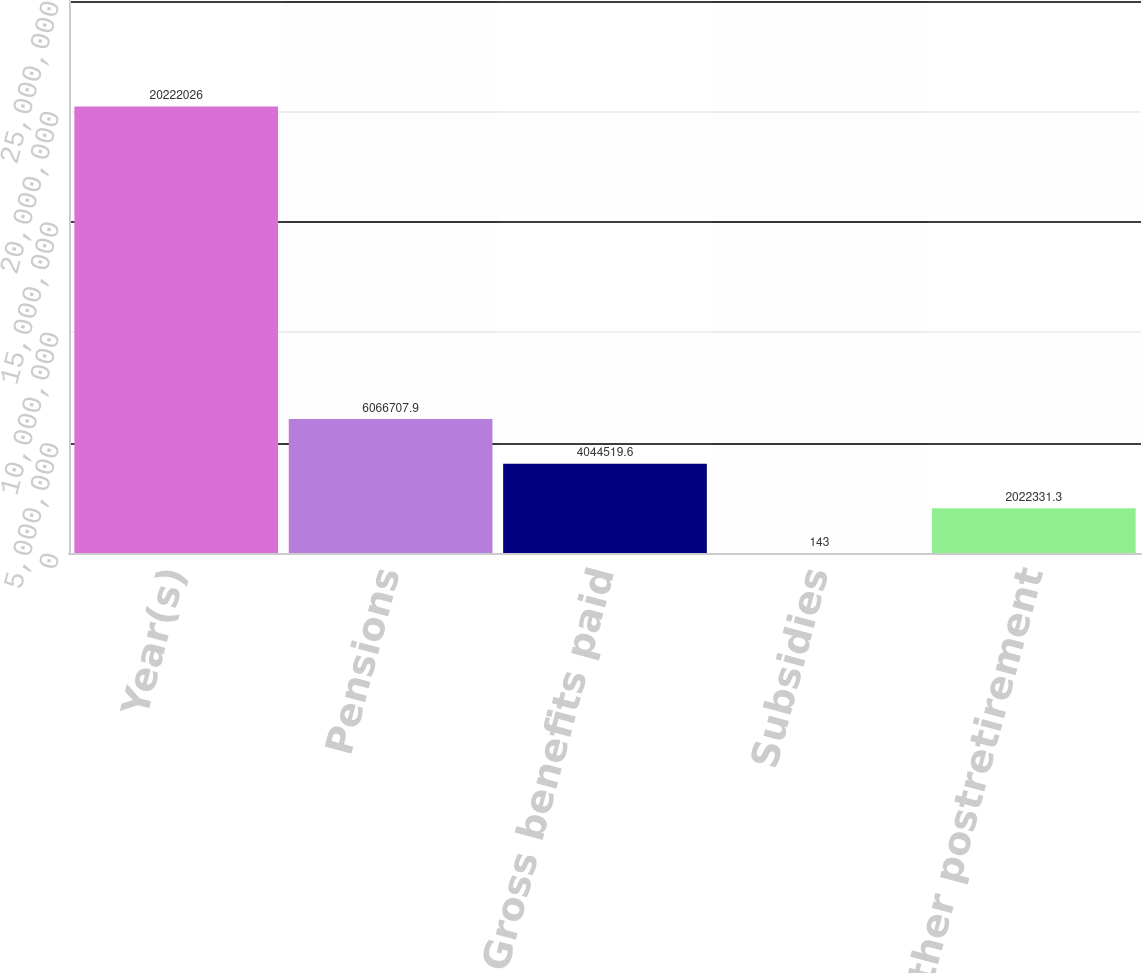Convert chart. <chart><loc_0><loc_0><loc_500><loc_500><bar_chart><fcel>Year(s)<fcel>Pensions<fcel>Gross benefits paid<fcel>Subsidies<fcel>Net other postretirement<nl><fcel>2.0222e+07<fcel>6.06671e+06<fcel>4.04452e+06<fcel>143<fcel>2.02233e+06<nl></chart> 